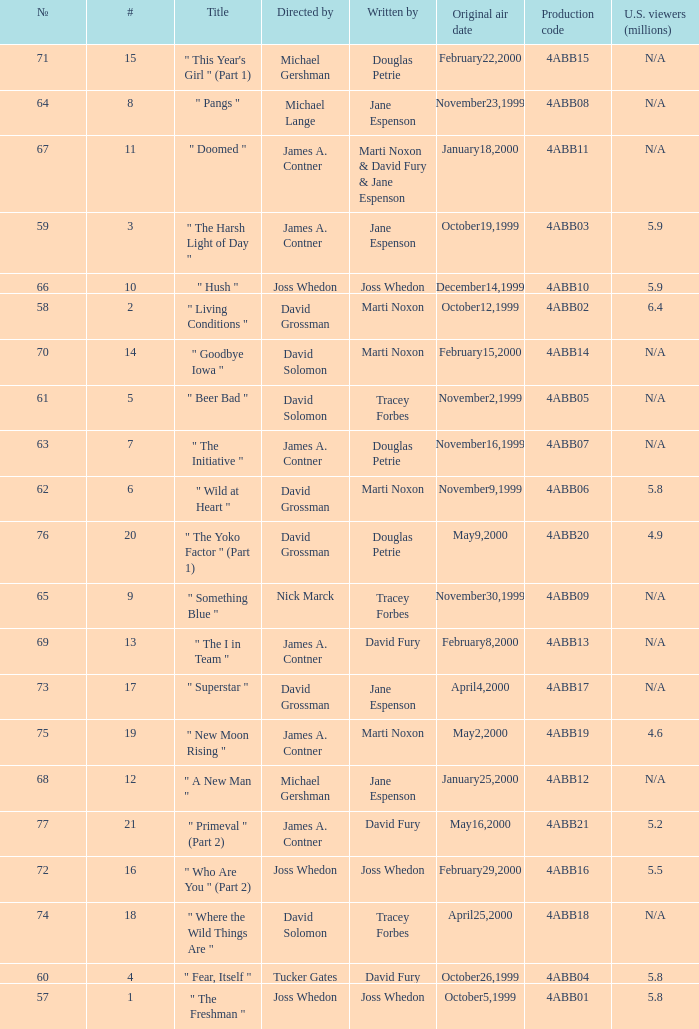What is the title of episode No. 65? " Something Blue ". 